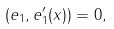<formula> <loc_0><loc_0><loc_500><loc_500>( e _ { 1 } , e _ { 1 } ^ { \prime } ( x ) ) = 0 ,</formula> 